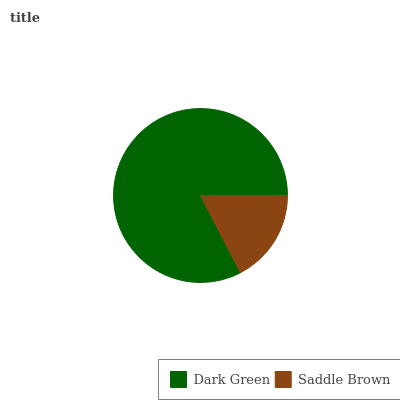Is Saddle Brown the minimum?
Answer yes or no. Yes. Is Dark Green the maximum?
Answer yes or no. Yes. Is Saddle Brown the maximum?
Answer yes or no. No. Is Dark Green greater than Saddle Brown?
Answer yes or no. Yes. Is Saddle Brown less than Dark Green?
Answer yes or no. Yes. Is Saddle Brown greater than Dark Green?
Answer yes or no. No. Is Dark Green less than Saddle Brown?
Answer yes or no. No. Is Dark Green the high median?
Answer yes or no. Yes. Is Saddle Brown the low median?
Answer yes or no. Yes. Is Saddle Brown the high median?
Answer yes or no. No. Is Dark Green the low median?
Answer yes or no. No. 